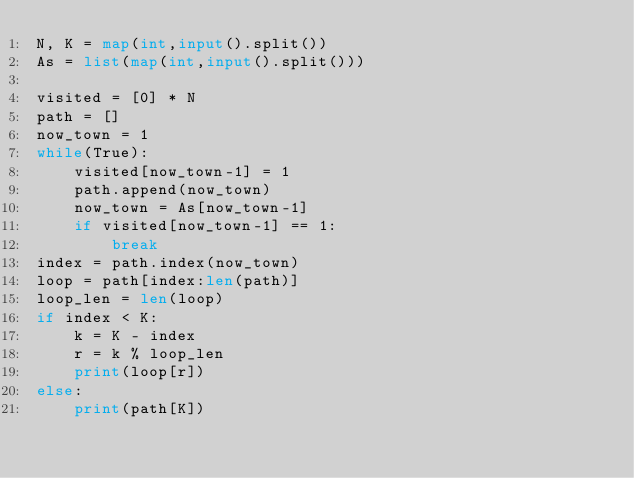Convert code to text. <code><loc_0><loc_0><loc_500><loc_500><_Python_>N, K = map(int,input().split())
As = list(map(int,input().split()))

visited = [0] * N
path = []
now_town = 1
while(True):
    visited[now_town-1] = 1
    path.append(now_town)
    now_town = As[now_town-1]
    if visited[now_town-1] == 1:
        break
index = path.index(now_town)
loop = path[index:len(path)]
loop_len = len(loop)
if index < K:
    k = K - index
    r = k % loop_len
    print(loop[r])
else:
    print(path[K])
</code> 